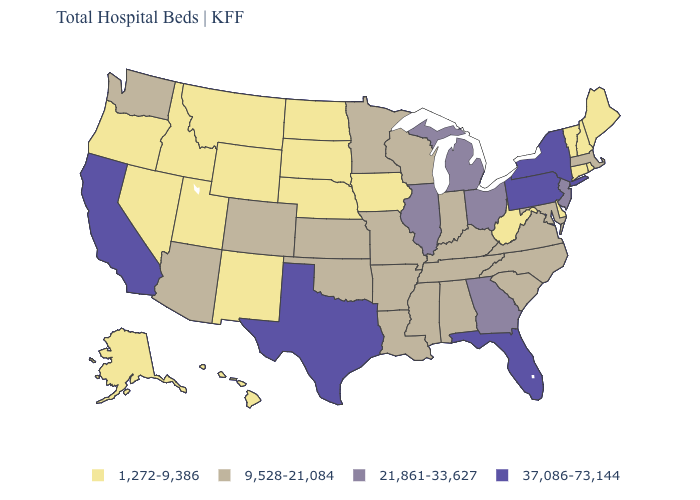What is the value of Nebraska?
Give a very brief answer. 1,272-9,386. Among the states that border Missouri , which have the lowest value?
Keep it brief. Iowa, Nebraska. What is the value of West Virginia?
Write a very short answer. 1,272-9,386. Name the states that have a value in the range 1,272-9,386?
Write a very short answer. Alaska, Connecticut, Delaware, Hawaii, Idaho, Iowa, Maine, Montana, Nebraska, Nevada, New Hampshire, New Mexico, North Dakota, Oregon, Rhode Island, South Dakota, Utah, Vermont, West Virginia, Wyoming. What is the value of Kansas?
Write a very short answer. 9,528-21,084. Does Kansas have a higher value than New Jersey?
Short answer required. No. Does Ohio have the highest value in the MidWest?
Short answer required. Yes. Which states have the lowest value in the USA?
Be succinct. Alaska, Connecticut, Delaware, Hawaii, Idaho, Iowa, Maine, Montana, Nebraska, Nevada, New Hampshire, New Mexico, North Dakota, Oregon, Rhode Island, South Dakota, Utah, Vermont, West Virginia, Wyoming. What is the value of Pennsylvania?
Give a very brief answer. 37,086-73,144. Does Delaware have the lowest value in the USA?
Short answer required. Yes. Does the map have missing data?
Short answer required. No. Does Idaho have the highest value in the USA?
Answer briefly. No. What is the lowest value in the Northeast?
Concise answer only. 1,272-9,386. How many symbols are there in the legend?
Quick response, please. 4. Does New York have a higher value than Pennsylvania?
Answer briefly. No. 